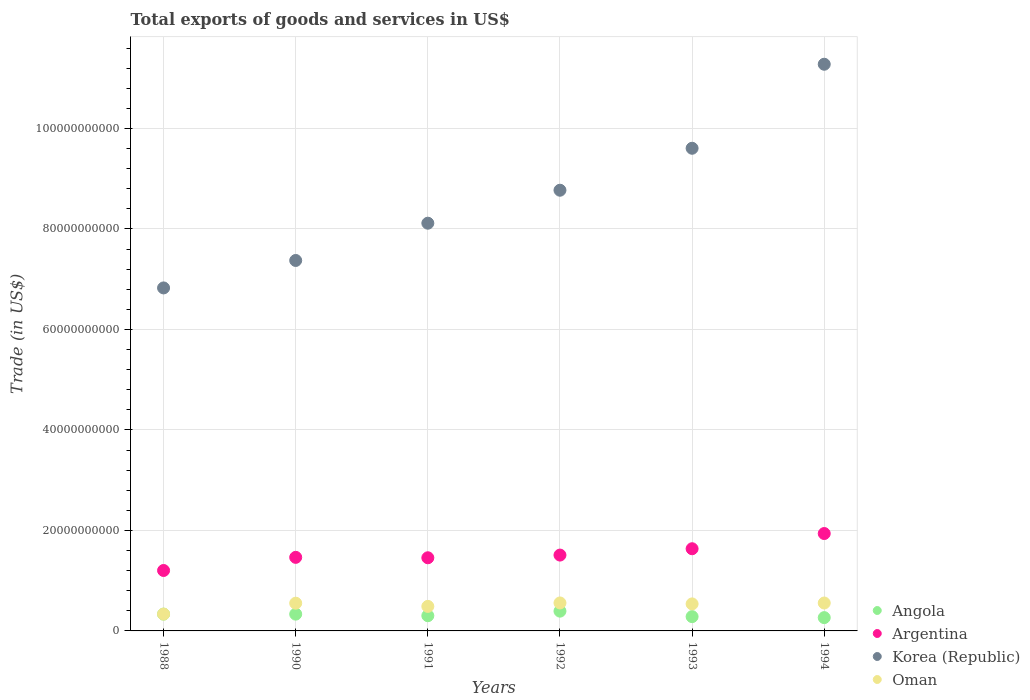How many different coloured dotlines are there?
Make the answer very short. 4. Is the number of dotlines equal to the number of legend labels?
Provide a succinct answer. Yes. What is the total exports of goods and services in Angola in 1994?
Offer a very short reply. 2.65e+09. Across all years, what is the maximum total exports of goods and services in Argentina?
Your response must be concise. 1.94e+1. Across all years, what is the minimum total exports of goods and services in Angola?
Provide a short and direct response. 2.65e+09. In which year was the total exports of goods and services in Angola maximum?
Your response must be concise. 1992. In which year was the total exports of goods and services in Angola minimum?
Keep it short and to the point. 1994. What is the total total exports of goods and services in Argentina in the graph?
Your answer should be compact. 9.21e+1. What is the difference between the total exports of goods and services in Korea (Republic) in 1988 and that in 1991?
Make the answer very short. -1.29e+1. What is the difference between the total exports of goods and services in Argentina in 1988 and the total exports of goods and services in Korea (Republic) in 1992?
Make the answer very short. -7.57e+1. What is the average total exports of goods and services in Korea (Republic) per year?
Offer a terse response. 8.66e+1. In the year 1993, what is the difference between the total exports of goods and services in Argentina and total exports of goods and services in Oman?
Keep it short and to the point. 1.10e+1. What is the ratio of the total exports of goods and services in Oman in 1988 to that in 1992?
Your response must be concise. 0.6. What is the difference between the highest and the second highest total exports of goods and services in Argentina?
Your answer should be compact. 3.03e+09. What is the difference between the highest and the lowest total exports of goods and services in Argentina?
Provide a short and direct response. 7.36e+09. Is the sum of the total exports of goods and services in Angola in 1988 and 1990 greater than the maximum total exports of goods and services in Oman across all years?
Give a very brief answer. Yes. Is it the case that in every year, the sum of the total exports of goods and services in Argentina and total exports of goods and services in Angola  is greater than the sum of total exports of goods and services in Oman and total exports of goods and services in Korea (Republic)?
Give a very brief answer. Yes. Does the total exports of goods and services in Argentina monotonically increase over the years?
Your answer should be compact. No. Is the total exports of goods and services in Oman strictly greater than the total exports of goods and services in Angola over the years?
Make the answer very short. Yes. Is the total exports of goods and services in Korea (Republic) strictly less than the total exports of goods and services in Angola over the years?
Keep it short and to the point. No. How many years are there in the graph?
Provide a short and direct response. 6. What is the difference between two consecutive major ticks on the Y-axis?
Provide a succinct answer. 2.00e+1. Where does the legend appear in the graph?
Offer a terse response. Bottom right. How are the legend labels stacked?
Offer a very short reply. Vertical. What is the title of the graph?
Your answer should be very brief. Total exports of goods and services in US$. Does "Grenada" appear as one of the legend labels in the graph?
Provide a short and direct response. No. What is the label or title of the X-axis?
Your response must be concise. Years. What is the label or title of the Y-axis?
Keep it short and to the point. Trade (in US$). What is the Trade (in US$) in Angola in 1988?
Give a very brief answer. 3.34e+09. What is the Trade (in US$) in Argentina in 1988?
Offer a very short reply. 1.20e+1. What is the Trade (in US$) in Korea (Republic) in 1988?
Your response must be concise. 6.83e+1. What is the Trade (in US$) in Oman in 1988?
Ensure brevity in your answer.  3.36e+09. What is the Trade (in US$) of Angola in 1990?
Your response must be concise. 3.34e+09. What is the Trade (in US$) in Argentina in 1990?
Ensure brevity in your answer.  1.46e+1. What is the Trade (in US$) in Korea (Republic) in 1990?
Your answer should be compact. 7.37e+1. What is the Trade (in US$) in Oman in 1990?
Offer a very short reply. 5.52e+09. What is the Trade (in US$) in Angola in 1991?
Provide a short and direct response. 3.03e+09. What is the Trade (in US$) of Argentina in 1991?
Your answer should be compact. 1.46e+1. What is the Trade (in US$) of Korea (Republic) in 1991?
Provide a succinct answer. 8.12e+1. What is the Trade (in US$) of Oman in 1991?
Your response must be concise. 4.88e+09. What is the Trade (in US$) in Angola in 1992?
Make the answer very short. 3.94e+09. What is the Trade (in US$) of Argentina in 1992?
Your answer should be compact. 1.51e+1. What is the Trade (in US$) in Korea (Republic) in 1992?
Offer a very short reply. 8.77e+1. What is the Trade (in US$) of Oman in 1992?
Offer a very short reply. 5.57e+09. What is the Trade (in US$) in Angola in 1993?
Offer a terse response. 2.85e+09. What is the Trade (in US$) in Argentina in 1993?
Your response must be concise. 1.64e+1. What is the Trade (in US$) in Korea (Republic) in 1993?
Offer a very short reply. 9.61e+1. What is the Trade (in US$) in Oman in 1993?
Keep it short and to the point. 5.38e+09. What is the Trade (in US$) of Angola in 1994?
Your answer should be very brief. 2.65e+09. What is the Trade (in US$) of Argentina in 1994?
Make the answer very short. 1.94e+1. What is the Trade (in US$) in Korea (Republic) in 1994?
Give a very brief answer. 1.13e+11. What is the Trade (in US$) in Oman in 1994?
Make the answer very short. 5.56e+09. Across all years, what is the maximum Trade (in US$) of Angola?
Ensure brevity in your answer.  3.94e+09. Across all years, what is the maximum Trade (in US$) of Argentina?
Offer a very short reply. 1.94e+1. Across all years, what is the maximum Trade (in US$) of Korea (Republic)?
Offer a very short reply. 1.13e+11. Across all years, what is the maximum Trade (in US$) in Oman?
Your answer should be compact. 5.57e+09. Across all years, what is the minimum Trade (in US$) in Angola?
Your answer should be very brief. 2.65e+09. Across all years, what is the minimum Trade (in US$) of Argentina?
Ensure brevity in your answer.  1.20e+1. Across all years, what is the minimum Trade (in US$) of Korea (Republic)?
Provide a succinct answer. 6.83e+1. Across all years, what is the minimum Trade (in US$) of Oman?
Provide a short and direct response. 3.36e+09. What is the total Trade (in US$) in Angola in the graph?
Provide a succinct answer. 1.91e+1. What is the total Trade (in US$) in Argentina in the graph?
Keep it short and to the point. 9.21e+1. What is the total Trade (in US$) in Korea (Republic) in the graph?
Offer a terse response. 5.20e+11. What is the total Trade (in US$) in Oman in the graph?
Make the answer very short. 3.03e+1. What is the difference between the Trade (in US$) of Angola in 1988 and that in 1990?
Give a very brief answer. 0. What is the difference between the Trade (in US$) in Argentina in 1988 and that in 1990?
Your answer should be compact. -2.61e+09. What is the difference between the Trade (in US$) of Korea (Republic) in 1988 and that in 1990?
Offer a terse response. -5.46e+09. What is the difference between the Trade (in US$) in Oman in 1988 and that in 1990?
Offer a terse response. -2.16e+09. What is the difference between the Trade (in US$) of Angola in 1988 and that in 1991?
Your response must be concise. 3.13e+08. What is the difference between the Trade (in US$) in Argentina in 1988 and that in 1991?
Ensure brevity in your answer.  -2.53e+09. What is the difference between the Trade (in US$) of Korea (Republic) in 1988 and that in 1991?
Provide a succinct answer. -1.29e+1. What is the difference between the Trade (in US$) of Oman in 1988 and that in 1991?
Provide a succinct answer. -1.53e+09. What is the difference between the Trade (in US$) of Angola in 1988 and that in 1992?
Offer a terse response. -5.93e+08. What is the difference between the Trade (in US$) in Argentina in 1988 and that in 1992?
Your answer should be very brief. -3.07e+09. What is the difference between the Trade (in US$) in Korea (Republic) in 1988 and that in 1992?
Give a very brief answer. -1.94e+1. What is the difference between the Trade (in US$) of Oman in 1988 and that in 1992?
Provide a succinct answer. -2.21e+09. What is the difference between the Trade (in US$) of Angola in 1988 and that in 1993?
Offer a terse response. 4.97e+08. What is the difference between the Trade (in US$) in Argentina in 1988 and that in 1993?
Provide a short and direct response. -4.33e+09. What is the difference between the Trade (in US$) of Korea (Republic) in 1988 and that in 1993?
Provide a short and direct response. -2.78e+1. What is the difference between the Trade (in US$) in Oman in 1988 and that in 1993?
Offer a terse response. -2.02e+09. What is the difference between the Trade (in US$) of Angola in 1988 and that in 1994?
Ensure brevity in your answer.  6.95e+08. What is the difference between the Trade (in US$) in Argentina in 1988 and that in 1994?
Your answer should be compact. -7.36e+09. What is the difference between the Trade (in US$) in Korea (Republic) in 1988 and that in 1994?
Your response must be concise. -4.45e+1. What is the difference between the Trade (in US$) of Oman in 1988 and that in 1994?
Ensure brevity in your answer.  -2.20e+09. What is the difference between the Trade (in US$) in Angola in 1990 and that in 1991?
Make the answer very short. 3.13e+08. What is the difference between the Trade (in US$) in Argentina in 1990 and that in 1991?
Provide a succinct answer. 8.24e+07. What is the difference between the Trade (in US$) of Korea (Republic) in 1990 and that in 1991?
Your response must be concise. -7.42e+09. What is the difference between the Trade (in US$) of Oman in 1990 and that in 1991?
Make the answer very short. 6.35e+08. What is the difference between the Trade (in US$) of Angola in 1990 and that in 1992?
Keep it short and to the point. -5.93e+08. What is the difference between the Trade (in US$) of Argentina in 1990 and that in 1992?
Keep it short and to the point. -4.52e+08. What is the difference between the Trade (in US$) in Korea (Republic) in 1990 and that in 1992?
Give a very brief answer. -1.40e+1. What is the difference between the Trade (in US$) in Oman in 1990 and that in 1992?
Provide a succinct answer. -4.94e+07. What is the difference between the Trade (in US$) of Angola in 1990 and that in 1993?
Your response must be concise. 4.97e+08. What is the difference between the Trade (in US$) of Argentina in 1990 and that in 1993?
Make the answer very short. -1.71e+09. What is the difference between the Trade (in US$) in Korea (Republic) in 1990 and that in 1993?
Provide a short and direct response. -2.23e+1. What is the difference between the Trade (in US$) of Oman in 1990 and that in 1993?
Ensure brevity in your answer.  1.40e+08. What is the difference between the Trade (in US$) of Angola in 1990 and that in 1994?
Offer a terse response. 6.95e+08. What is the difference between the Trade (in US$) of Argentina in 1990 and that in 1994?
Ensure brevity in your answer.  -4.74e+09. What is the difference between the Trade (in US$) of Korea (Republic) in 1990 and that in 1994?
Ensure brevity in your answer.  -3.91e+1. What is the difference between the Trade (in US$) of Oman in 1990 and that in 1994?
Keep it short and to the point. -3.64e+07. What is the difference between the Trade (in US$) of Angola in 1991 and that in 1992?
Offer a very short reply. -9.06e+08. What is the difference between the Trade (in US$) in Argentina in 1991 and that in 1992?
Your answer should be very brief. -5.35e+08. What is the difference between the Trade (in US$) in Korea (Republic) in 1991 and that in 1992?
Ensure brevity in your answer.  -6.56e+09. What is the difference between the Trade (in US$) of Oman in 1991 and that in 1992?
Ensure brevity in your answer.  -6.84e+08. What is the difference between the Trade (in US$) of Angola in 1991 and that in 1993?
Make the answer very short. 1.85e+08. What is the difference between the Trade (in US$) in Argentina in 1991 and that in 1993?
Give a very brief answer. -1.80e+09. What is the difference between the Trade (in US$) of Korea (Republic) in 1991 and that in 1993?
Offer a very short reply. -1.49e+1. What is the difference between the Trade (in US$) of Oman in 1991 and that in 1993?
Provide a short and direct response. -4.94e+08. What is the difference between the Trade (in US$) of Angola in 1991 and that in 1994?
Your answer should be very brief. 3.83e+08. What is the difference between the Trade (in US$) in Argentina in 1991 and that in 1994?
Keep it short and to the point. -4.82e+09. What is the difference between the Trade (in US$) of Korea (Republic) in 1991 and that in 1994?
Your answer should be compact. -3.16e+1. What is the difference between the Trade (in US$) of Oman in 1991 and that in 1994?
Your response must be concise. -6.71e+08. What is the difference between the Trade (in US$) in Angola in 1992 and that in 1993?
Your response must be concise. 1.09e+09. What is the difference between the Trade (in US$) of Argentina in 1992 and that in 1993?
Your response must be concise. -1.26e+09. What is the difference between the Trade (in US$) in Korea (Republic) in 1992 and that in 1993?
Offer a terse response. -8.35e+09. What is the difference between the Trade (in US$) in Oman in 1992 and that in 1993?
Give a very brief answer. 1.90e+08. What is the difference between the Trade (in US$) of Angola in 1992 and that in 1994?
Offer a terse response. 1.29e+09. What is the difference between the Trade (in US$) in Argentina in 1992 and that in 1994?
Your response must be concise. -4.29e+09. What is the difference between the Trade (in US$) of Korea (Republic) in 1992 and that in 1994?
Your response must be concise. -2.51e+1. What is the difference between the Trade (in US$) in Oman in 1992 and that in 1994?
Provide a succinct answer. 1.30e+07. What is the difference between the Trade (in US$) in Angola in 1993 and that in 1994?
Make the answer very short. 1.98e+08. What is the difference between the Trade (in US$) of Argentina in 1993 and that in 1994?
Your response must be concise. -3.03e+09. What is the difference between the Trade (in US$) of Korea (Republic) in 1993 and that in 1994?
Provide a short and direct response. -1.67e+1. What is the difference between the Trade (in US$) of Oman in 1993 and that in 1994?
Provide a short and direct response. -1.77e+08. What is the difference between the Trade (in US$) of Angola in 1988 and the Trade (in US$) of Argentina in 1990?
Provide a short and direct response. -1.13e+1. What is the difference between the Trade (in US$) of Angola in 1988 and the Trade (in US$) of Korea (Republic) in 1990?
Ensure brevity in your answer.  -7.04e+1. What is the difference between the Trade (in US$) in Angola in 1988 and the Trade (in US$) in Oman in 1990?
Offer a terse response. -2.18e+09. What is the difference between the Trade (in US$) of Argentina in 1988 and the Trade (in US$) of Korea (Republic) in 1990?
Your response must be concise. -6.17e+1. What is the difference between the Trade (in US$) in Argentina in 1988 and the Trade (in US$) in Oman in 1990?
Keep it short and to the point. 6.51e+09. What is the difference between the Trade (in US$) in Korea (Republic) in 1988 and the Trade (in US$) in Oman in 1990?
Ensure brevity in your answer.  6.28e+1. What is the difference between the Trade (in US$) in Angola in 1988 and the Trade (in US$) in Argentina in 1991?
Your answer should be very brief. -1.12e+1. What is the difference between the Trade (in US$) in Angola in 1988 and the Trade (in US$) in Korea (Republic) in 1991?
Make the answer very short. -7.78e+1. What is the difference between the Trade (in US$) in Angola in 1988 and the Trade (in US$) in Oman in 1991?
Ensure brevity in your answer.  -1.54e+09. What is the difference between the Trade (in US$) of Argentina in 1988 and the Trade (in US$) of Korea (Republic) in 1991?
Make the answer very short. -6.91e+1. What is the difference between the Trade (in US$) in Argentina in 1988 and the Trade (in US$) in Oman in 1991?
Keep it short and to the point. 7.15e+09. What is the difference between the Trade (in US$) of Korea (Republic) in 1988 and the Trade (in US$) of Oman in 1991?
Give a very brief answer. 6.34e+1. What is the difference between the Trade (in US$) of Angola in 1988 and the Trade (in US$) of Argentina in 1992?
Give a very brief answer. -1.18e+1. What is the difference between the Trade (in US$) in Angola in 1988 and the Trade (in US$) in Korea (Republic) in 1992?
Your answer should be very brief. -8.44e+1. What is the difference between the Trade (in US$) in Angola in 1988 and the Trade (in US$) in Oman in 1992?
Your response must be concise. -2.23e+09. What is the difference between the Trade (in US$) in Argentina in 1988 and the Trade (in US$) in Korea (Republic) in 1992?
Offer a very short reply. -7.57e+1. What is the difference between the Trade (in US$) of Argentina in 1988 and the Trade (in US$) of Oman in 1992?
Your response must be concise. 6.46e+09. What is the difference between the Trade (in US$) in Korea (Republic) in 1988 and the Trade (in US$) in Oman in 1992?
Give a very brief answer. 6.27e+1. What is the difference between the Trade (in US$) of Angola in 1988 and the Trade (in US$) of Argentina in 1993?
Your response must be concise. -1.30e+1. What is the difference between the Trade (in US$) in Angola in 1988 and the Trade (in US$) in Korea (Republic) in 1993?
Your answer should be compact. -9.27e+1. What is the difference between the Trade (in US$) in Angola in 1988 and the Trade (in US$) in Oman in 1993?
Your answer should be compact. -2.04e+09. What is the difference between the Trade (in US$) of Argentina in 1988 and the Trade (in US$) of Korea (Republic) in 1993?
Offer a very short reply. -8.40e+1. What is the difference between the Trade (in US$) in Argentina in 1988 and the Trade (in US$) in Oman in 1993?
Your answer should be compact. 6.65e+09. What is the difference between the Trade (in US$) of Korea (Republic) in 1988 and the Trade (in US$) of Oman in 1993?
Your answer should be compact. 6.29e+1. What is the difference between the Trade (in US$) of Angola in 1988 and the Trade (in US$) of Argentina in 1994?
Make the answer very short. -1.60e+1. What is the difference between the Trade (in US$) of Angola in 1988 and the Trade (in US$) of Korea (Republic) in 1994?
Offer a terse response. -1.09e+11. What is the difference between the Trade (in US$) in Angola in 1988 and the Trade (in US$) in Oman in 1994?
Ensure brevity in your answer.  -2.21e+09. What is the difference between the Trade (in US$) of Argentina in 1988 and the Trade (in US$) of Korea (Republic) in 1994?
Keep it short and to the point. -1.01e+11. What is the difference between the Trade (in US$) in Argentina in 1988 and the Trade (in US$) in Oman in 1994?
Your response must be concise. 6.47e+09. What is the difference between the Trade (in US$) in Korea (Republic) in 1988 and the Trade (in US$) in Oman in 1994?
Ensure brevity in your answer.  6.27e+1. What is the difference between the Trade (in US$) in Angola in 1990 and the Trade (in US$) in Argentina in 1991?
Offer a terse response. -1.12e+1. What is the difference between the Trade (in US$) of Angola in 1990 and the Trade (in US$) of Korea (Republic) in 1991?
Offer a very short reply. -7.78e+1. What is the difference between the Trade (in US$) in Angola in 1990 and the Trade (in US$) in Oman in 1991?
Keep it short and to the point. -1.54e+09. What is the difference between the Trade (in US$) in Argentina in 1990 and the Trade (in US$) in Korea (Republic) in 1991?
Provide a succinct answer. -6.65e+1. What is the difference between the Trade (in US$) in Argentina in 1990 and the Trade (in US$) in Oman in 1991?
Make the answer very short. 9.76e+09. What is the difference between the Trade (in US$) of Korea (Republic) in 1990 and the Trade (in US$) of Oman in 1991?
Offer a very short reply. 6.89e+1. What is the difference between the Trade (in US$) in Angola in 1990 and the Trade (in US$) in Argentina in 1992?
Provide a succinct answer. -1.18e+1. What is the difference between the Trade (in US$) of Angola in 1990 and the Trade (in US$) of Korea (Republic) in 1992?
Offer a very short reply. -8.44e+1. What is the difference between the Trade (in US$) in Angola in 1990 and the Trade (in US$) in Oman in 1992?
Provide a succinct answer. -2.23e+09. What is the difference between the Trade (in US$) of Argentina in 1990 and the Trade (in US$) of Korea (Republic) in 1992?
Provide a succinct answer. -7.31e+1. What is the difference between the Trade (in US$) in Argentina in 1990 and the Trade (in US$) in Oman in 1992?
Your response must be concise. 9.08e+09. What is the difference between the Trade (in US$) in Korea (Republic) in 1990 and the Trade (in US$) in Oman in 1992?
Your answer should be very brief. 6.82e+1. What is the difference between the Trade (in US$) in Angola in 1990 and the Trade (in US$) in Argentina in 1993?
Make the answer very short. -1.30e+1. What is the difference between the Trade (in US$) in Angola in 1990 and the Trade (in US$) in Korea (Republic) in 1993?
Keep it short and to the point. -9.27e+1. What is the difference between the Trade (in US$) of Angola in 1990 and the Trade (in US$) of Oman in 1993?
Your answer should be compact. -2.04e+09. What is the difference between the Trade (in US$) in Argentina in 1990 and the Trade (in US$) in Korea (Republic) in 1993?
Your response must be concise. -8.14e+1. What is the difference between the Trade (in US$) of Argentina in 1990 and the Trade (in US$) of Oman in 1993?
Ensure brevity in your answer.  9.27e+09. What is the difference between the Trade (in US$) of Korea (Republic) in 1990 and the Trade (in US$) of Oman in 1993?
Make the answer very short. 6.84e+1. What is the difference between the Trade (in US$) in Angola in 1990 and the Trade (in US$) in Argentina in 1994?
Your answer should be very brief. -1.60e+1. What is the difference between the Trade (in US$) of Angola in 1990 and the Trade (in US$) of Korea (Republic) in 1994?
Provide a short and direct response. -1.09e+11. What is the difference between the Trade (in US$) in Angola in 1990 and the Trade (in US$) in Oman in 1994?
Your answer should be compact. -2.21e+09. What is the difference between the Trade (in US$) in Argentina in 1990 and the Trade (in US$) in Korea (Republic) in 1994?
Provide a short and direct response. -9.81e+1. What is the difference between the Trade (in US$) in Argentina in 1990 and the Trade (in US$) in Oman in 1994?
Your answer should be compact. 9.09e+09. What is the difference between the Trade (in US$) of Korea (Republic) in 1990 and the Trade (in US$) of Oman in 1994?
Your answer should be compact. 6.82e+1. What is the difference between the Trade (in US$) of Angola in 1991 and the Trade (in US$) of Argentina in 1992?
Provide a short and direct response. -1.21e+1. What is the difference between the Trade (in US$) in Angola in 1991 and the Trade (in US$) in Korea (Republic) in 1992?
Offer a very short reply. -8.47e+1. What is the difference between the Trade (in US$) of Angola in 1991 and the Trade (in US$) of Oman in 1992?
Your answer should be very brief. -2.54e+09. What is the difference between the Trade (in US$) of Argentina in 1991 and the Trade (in US$) of Korea (Republic) in 1992?
Offer a terse response. -7.32e+1. What is the difference between the Trade (in US$) in Argentina in 1991 and the Trade (in US$) in Oman in 1992?
Offer a terse response. 8.99e+09. What is the difference between the Trade (in US$) in Korea (Republic) in 1991 and the Trade (in US$) in Oman in 1992?
Make the answer very short. 7.56e+1. What is the difference between the Trade (in US$) in Angola in 1991 and the Trade (in US$) in Argentina in 1993?
Offer a very short reply. -1.33e+1. What is the difference between the Trade (in US$) in Angola in 1991 and the Trade (in US$) in Korea (Republic) in 1993?
Your answer should be very brief. -9.30e+1. What is the difference between the Trade (in US$) in Angola in 1991 and the Trade (in US$) in Oman in 1993?
Offer a very short reply. -2.35e+09. What is the difference between the Trade (in US$) of Argentina in 1991 and the Trade (in US$) of Korea (Republic) in 1993?
Make the answer very short. -8.15e+1. What is the difference between the Trade (in US$) in Argentina in 1991 and the Trade (in US$) in Oman in 1993?
Ensure brevity in your answer.  9.18e+09. What is the difference between the Trade (in US$) in Korea (Republic) in 1991 and the Trade (in US$) in Oman in 1993?
Keep it short and to the point. 7.58e+1. What is the difference between the Trade (in US$) in Angola in 1991 and the Trade (in US$) in Argentina in 1994?
Give a very brief answer. -1.64e+1. What is the difference between the Trade (in US$) of Angola in 1991 and the Trade (in US$) of Korea (Republic) in 1994?
Offer a very short reply. -1.10e+11. What is the difference between the Trade (in US$) in Angola in 1991 and the Trade (in US$) in Oman in 1994?
Your answer should be very brief. -2.53e+09. What is the difference between the Trade (in US$) in Argentina in 1991 and the Trade (in US$) in Korea (Republic) in 1994?
Your response must be concise. -9.82e+1. What is the difference between the Trade (in US$) of Argentina in 1991 and the Trade (in US$) of Oman in 1994?
Make the answer very short. 9.01e+09. What is the difference between the Trade (in US$) in Korea (Republic) in 1991 and the Trade (in US$) in Oman in 1994?
Make the answer very short. 7.56e+1. What is the difference between the Trade (in US$) of Angola in 1992 and the Trade (in US$) of Argentina in 1993?
Your answer should be compact. -1.24e+1. What is the difference between the Trade (in US$) in Angola in 1992 and the Trade (in US$) in Korea (Republic) in 1993?
Offer a terse response. -9.21e+1. What is the difference between the Trade (in US$) in Angola in 1992 and the Trade (in US$) in Oman in 1993?
Keep it short and to the point. -1.44e+09. What is the difference between the Trade (in US$) of Argentina in 1992 and the Trade (in US$) of Korea (Republic) in 1993?
Provide a succinct answer. -8.10e+1. What is the difference between the Trade (in US$) in Argentina in 1992 and the Trade (in US$) in Oman in 1993?
Offer a very short reply. 9.72e+09. What is the difference between the Trade (in US$) in Korea (Republic) in 1992 and the Trade (in US$) in Oman in 1993?
Provide a short and direct response. 8.23e+1. What is the difference between the Trade (in US$) of Angola in 1992 and the Trade (in US$) of Argentina in 1994?
Provide a succinct answer. -1.54e+1. What is the difference between the Trade (in US$) of Angola in 1992 and the Trade (in US$) of Korea (Republic) in 1994?
Offer a very short reply. -1.09e+11. What is the difference between the Trade (in US$) in Angola in 1992 and the Trade (in US$) in Oman in 1994?
Make the answer very short. -1.62e+09. What is the difference between the Trade (in US$) in Argentina in 1992 and the Trade (in US$) in Korea (Republic) in 1994?
Your response must be concise. -9.77e+1. What is the difference between the Trade (in US$) in Argentina in 1992 and the Trade (in US$) in Oman in 1994?
Provide a succinct answer. 9.54e+09. What is the difference between the Trade (in US$) of Korea (Republic) in 1992 and the Trade (in US$) of Oman in 1994?
Provide a short and direct response. 8.22e+1. What is the difference between the Trade (in US$) of Angola in 1993 and the Trade (in US$) of Argentina in 1994?
Your answer should be very brief. -1.65e+1. What is the difference between the Trade (in US$) of Angola in 1993 and the Trade (in US$) of Korea (Republic) in 1994?
Offer a terse response. -1.10e+11. What is the difference between the Trade (in US$) of Angola in 1993 and the Trade (in US$) of Oman in 1994?
Your answer should be very brief. -2.71e+09. What is the difference between the Trade (in US$) in Argentina in 1993 and the Trade (in US$) in Korea (Republic) in 1994?
Your response must be concise. -9.64e+1. What is the difference between the Trade (in US$) in Argentina in 1993 and the Trade (in US$) in Oman in 1994?
Your response must be concise. 1.08e+1. What is the difference between the Trade (in US$) in Korea (Republic) in 1993 and the Trade (in US$) in Oman in 1994?
Provide a succinct answer. 9.05e+1. What is the average Trade (in US$) in Angola per year?
Give a very brief answer. 3.19e+09. What is the average Trade (in US$) of Argentina per year?
Make the answer very short. 1.53e+1. What is the average Trade (in US$) in Korea (Republic) per year?
Offer a terse response. 8.66e+1. What is the average Trade (in US$) of Oman per year?
Make the answer very short. 5.04e+09. In the year 1988, what is the difference between the Trade (in US$) of Angola and Trade (in US$) of Argentina?
Give a very brief answer. -8.69e+09. In the year 1988, what is the difference between the Trade (in US$) in Angola and Trade (in US$) in Korea (Republic)?
Offer a terse response. -6.49e+1. In the year 1988, what is the difference between the Trade (in US$) of Angola and Trade (in US$) of Oman?
Provide a short and direct response. -1.28e+07. In the year 1988, what is the difference between the Trade (in US$) in Argentina and Trade (in US$) in Korea (Republic)?
Your answer should be compact. -5.62e+1. In the year 1988, what is the difference between the Trade (in US$) in Argentina and Trade (in US$) in Oman?
Offer a terse response. 8.67e+09. In the year 1988, what is the difference between the Trade (in US$) in Korea (Republic) and Trade (in US$) in Oman?
Make the answer very short. 6.49e+1. In the year 1990, what is the difference between the Trade (in US$) in Angola and Trade (in US$) in Argentina?
Your answer should be very brief. -1.13e+1. In the year 1990, what is the difference between the Trade (in US$) in Angola and Trade (in US$) in Korea (Republic)?
Provide a succinct answer. -7.04e+1. In the year 1990, what is the difference between the Trade (in US$) in Angola and Trade (in US$) in Oman?
Ensure brevity in your answer.  -2.18e+09. In the year 1990, what is the difference between the Trade (in US$) in Argentina and Trade (in US$) in Korea (Republic)?
Offer a very short reply. -5.91e+1. In the year 1990, what is the difference between the Trade (in US$) of Argentina and Trade (in US$) of Oman?
Offer a terse response. 9.12e+09. In the year 1990, what is the difference between the Trade (in US$) of Korea (Republic) and Trade (in US$) of Oman?
Offer a terse response. 6.82e+1. In the year 1991, what is the difference between the Trade (in US$) in Angola and Trade (in US$) in Argentina?
Offer a terse response. -1.15e+1. In the year 1991, what is the difference between the Trade (in US$) of Angola and Trade (in US$) of Korea (Republic)?
Your answer should be very brief. -7.81e+1. In the year 1991, what is the difference between the Trade (in US$) of Angola and Trade (in US$) of Oman?
Give a very brief answer. -1.85e+09. In the year 1991, what is the difference between the Trade (in US$) in Argentina and Trade (in US$) in Korea (Republic)?
Ensure brevity in your answer.  -6.66e+1. In the year 1991, what is the difference between the Trade (in US$) in Argentina and Trade (in US$) in Oman?
Your response must be concise. 9.68e+09. In the year 1991, what is the difference between the Trade (in US$) in Korea (Republic) and Trade (in US$) in Oman?
Provide a succinct answer. 7.63e+1. In the year 1992, what is the difference between the Trade (in US$) in Angola and Trade (in US$) in Argentina?
Keep it short and to the point. -1.12e+1. In the year 1992, what is the difference between the Trade (in US$) of Angola and Trade (in US$) of Korea (Republic)?
Provide a succinct answer. -8.38e+1. In the year 1992, what is the difference between the Trade (in US$) of Angola and Trade (in US$) of Oman?
Keep it short and to the point. -1.63e+09. In the year 1992, what is the difference between the Trade (in US$) of Argentina and Trade (in US$) of Korea (Republic)?
Provide a short and direct response. -7.26e+1. In the year 1992, what is the difference between the Trade (in US$) of Argentina and Trade (in US$) of Oman?
Your answer should be very brief. 9.53e+09. In the year 1992, what is the difference between the Trade (in US$) of Korea (Republic) and Trade (in US$) of Oman?
Ensure brevity in your answer.  8.21e+1. In the year 1993, what is the difference between the Trade (in US$) in Angola and Trade (in US$) in Argentina?
Provide a succinct answer. -1.35e+1. In the year 1993, what is the difference between the Trade (in US$) in Angola and Trade (in US$) in Korea (Republic)?
Provide a succinct answer. -9.32e+1. In the year 1993, what is the difference between the Trade (in US$) in Angola and Trade (in US$) in Oman?
Keep it short and to the point. -2.53e+09. In the year 1993, what is the difference between the Trade (in US$) of Argentina and Trade (in US$) of Korea (Republic)?
Your answer should be compact. -7.97e+1. In the year 1993, what is the difference between the Trade (in US$) of Argentina and Trade (in US$) of Oman?
Offer a terse response. 1.10e+1. In the year 1993, what is the difference between the Trade (in US$) in Korea (Republic) and Trade (in US$) in Oman?
Make the answer very short. 9.07e+1. In the year 1994, what is the difference between the Trade (in US$) of Angola and Trade (in US$) of Argentina?
Offer a terse response. -1.67e+1. In the year 1994, what is the difference between the Trade (in US$) in Angola and Trade (in US$) in Korea (Republic)?
Your answer should be very brief. -1.10e+11. In the year 1994, what is the difference between the Trade (in US$) in Angola and Trade (in US$) in Oman?
Your response must be concise. -2.91e+09. In the year 1994, what is the difference between the Trade (in US$) of Argentina and Trade (in US$) of Korea (Republic)?
Provide a succinct answer. -9.34e+1. In the year 1994, what is the difference between the Trade (in US$) in Argentina and Trade (in US$) in Oman?
Make the answer very short. 1.38e+1. In the year 1994, what is the difference between the Trade (in US$) in Korea (Republic) and Trade (in US$) in Oman?
Make the answer very short. 1.07e+11. What is the ratio of the Trade (in US$) of Angola in 1988 to that in 1990?
Your answer should be compact. 1. What is the ratio of the Trade (in US$) in Argentina in 1988 to that in 1990?
Offer a terse response. 0.82. What is the ratio of the Trade (in US$) of Korea (Republic) in 1988 to that in 1990?
Your response must be concise. 0.93. What is the ratio of the Trade (in US$) of Oman in 1988 to that in 1990?
Offer a very short reply. 0.61. What is the ratio of the Trade (in US$) in Angola in 1988 to that in 1991?
Offer a terse response. 1.1. What is the ratio of the Trade (in US$) of Argentina in 1988 to that in 1991?
Your answer should be compact. 0.83. What is the ratio of the Trade (in US$) of Korea (Republic) in 1988 to that in 1991?
Your answer should be very brief. 0.84. What is the ratio of the Trade (in US$) of Oman in 1988 to that in 1991?
Offer a terse response. 0.69. What is the ratio of the Trade (in US$) in Angola in 1988 to that in 1992?
Provide a succinct answer. 0.85. What is the ratio of the Trade (in US$) in Argentina in 1988 to that in 1992?
Your response must be concise. 0.8. What is the ratio of the Trade (in US$) of Korea (Republic) in 1988 to that in 1992?
Make the answer very short. 0.78. What is the ratio of the Trade (in US$) of Oman in 1988 to that in 1992?
Keep it short and to the point. 0.6. What is the ratio of the Trade (in US$) in Angola in 1988 to that in 1993?
Offer a very short reply. 1.17. What is the ratio of the Trade (in US$) in Argentina in 1988 to that in 1993?
Ensure brevity in your answer.  0.74. What is the ratio of the Trade (in US$) in Korea (Republic) in 1988 to that in 1993?
Provide a short and direct response. 0.71. What is the ratio of the Trade (in US$) in Oman in 1988 to that in 1993?
Offer a terse response. 0.62. What is the ratio of the Trade (in US$) in Angola in 1988 to that in 1994?
Ensure brevity in your answer.  1.26. What is the ratio of the Trade (in US$) in Argentina in 1988 to that in 1994?
Your answer should be very brief. 0.62. What is the ratio of the Trade (in US$) of Korea (Republic) in 1988 to that in 1994?
Provide a succinct answer. 0.61. What is the ratio of the Trade (in US$) in Oman in 1988 to that in 1994?
Provide a succinct answer. 0.6. What is the ratio of the Trade (in US$) of Angola in 1990 to that in 1991?
Offer a very short reply. 1.1. What is the ratio of the Trade (in US$) of Korea (Republic) in 1990 to that in 1991?
Provide a short and direct response. 0.91. What is the ratio of the Trade (in US$) in Oman in 1990 to that in 1991?
Your answer should be compact. 1.13. What is the ratio of the Trade (in US$) in Angola in 1990 to that in 1992?
Keep it short and to the point. 0.85. What is the ratio of the Trade (in US$) in Korea (Republic) in 1990 to that in 1992?
Make the answer very short. 0.84. What is the ratio of the Trade (in US$) of Oman in 1990 to that in 1992?
Provide a succinct answer. 0.99. What is the ratio of the Trade (in US$) in Angola in 1990 to that in 1993?
Make the answer very short. 1.17. What is the ratio of the Trade (in US$) of Argentina in 1990 to that in 1993?
Your response must be concise. 0.9. What is the ratio of the Trade (in US$) in Korea (Republic) in 1990 to that in 1993?
Your answer should be very brief. 0.77. What is the ratio of the Trade (in US$) in Oman in 1990 to that in 1993?
Keep it short and to the point. 1.03. What is the ratio of the Trade (in US$) of Angola in 1990 to that in 1994?
Provide a succinct answer. 1.26. What is the ratio of the Trade (in US$) in Argentina in 1990 to that in 1994?
Your response must be concise. 0.76. What is the ratio of the Trade (in US$) of Korea (Republic) in 1990 to that in 1994?
Offer a very short reply. 0.65. What is the ratio of the Trade (in US$) in Oman in 1990 to that in 1994?
Offer a terse response. 0.99. What is the ratio of the Trade (in US$) of Angola in 1991 to that in 1992?
Make the answer very short. 0.77. What is the ratio of the Trade (in US$) in Argentina in 1991 to that in 1992?
Make the answer very short. 0.96. What is the ratio of the Trade (in US$) in Korea (Republic) in 1991 to that in 1992?
Ensure brevity in your answer.  0.93. What is the ratio of the Trade (in US$) in Oman in 1991 to that in 1992?
Ensure brevity in your answer.  0.88. What is the ratio of the Trade (in US$) of Angola in 1991 to that in 1993?
Ensure brevity in your answer.  1.06. What is the ratio of the Trade (in US$) of Argentina in 1991 to that in 1993?
Provide a short and direct response. 0.89. What is the ratio of the Trade (in US$) of Korea (Republic) in 1991 to that in 1993?
Keep it short and to the point. 0.84. What is the ratio of the Trade (in US$) of Oman in 1991 to that in 1993?
Provide a succinct answer. 0.91. What is the ratio of the Trade (in US$) in Angola in 1991 to that in 1994?
Your answer should be compact. 1.14. What is the ratio of the Trade (in US$) in Argentina in 1991 to that in 1994?
Provide a succinct answer. 0.75. What is the ratio of the Trade (in US$) of Korea (Republic) in 1991 to that in 1994?
Your response must be concise. 0.72. What is the ratio of the Trade (in US$) of Oman in 1991 to that in 1994?
Give a very brief answer. 0.88. What is the ratio of the Trade (in US$) in Angola in 1992 to that in 1993?
Make the answer very short. 1.38. What is the ratio of the Trade (in US$) in Argentina in 1992 to that in 1993?
Keep it short and to the point. 0.92. What is the ratio of the Trade (in US$) in Korea (Republic) in 1992 to that in 1993?
Your answer should be compact. 0.91. What is the ratio of the Trade (in US$) in Oman in 1992 to that in 1993?
Ensure brevity in your answer.  1.04. What is the ratio of the Trade (in US$) of Angola in 1992 to that in 1994?
Keep it short and to the point. 1.49. What is the ratio of the Trade (in US$) in Argentina in 1992 to that in 1994?
Provide a succinct answer. 0.78. What is the ratio of the Trade (in US$) of Korea (Republic) in 1992 to that in 1994?
Make the answer very short. 0.78. What is the ratio of the Trade (in US$) of Oman in 1992 to that in 1994?
Make the answer very short. 1. What is the ratio of the Trade (in US$) in Angola in 1993 to that in 1994?
Offer a very short reply. 1.07. What is the ratio of the Trade (in US$) of Argentina in 1993 to that in 1994?
Ensure brevity in your answer.  0.84. What is the ratio of the Trade (in US$) in Korea (Republic) in 1993 to that in 1994?
Ensure brevity in your answer.  0.85. What is the ratio of the Trade (in US$) in Oman in 1993 to that in 1994?
Keep it short and to the point. 0.97. What is the difference between the highest and the second highest Trade (in US$) of Angola?
Give a very brief answer. 5.93e+08. What is the difference between the highest and the second highest Trade (in US$) in Argentina?
Offer a very short reply. 3.03e+09. What is the difference between the highest and the second highest Trade (in US$) of Korea (Republic)?
Make the answer very short. 1.67e+1. What is the difference between the highest and the second highest Trade (in US$) of Oman?
Ensure brevity in your answer.  1.30e+07. What is the difference between the highest and the lowest Trade (in US$) in Angola?
Make the answer very short. 1.29e+09. What is the difference between the highest and the lowest Trade (in US$) in Argentina?
Your answer should be very brief. 7.36e+09. What is the difference between the highest and the lowest Trade (in US$) of Korea (Republic)?
Give a very brief answer. 4.45e+1. What is the difference between the highest and the lowest Trade (in US$) in Oman?
Keep it short and to the point. 2.21e+09. 